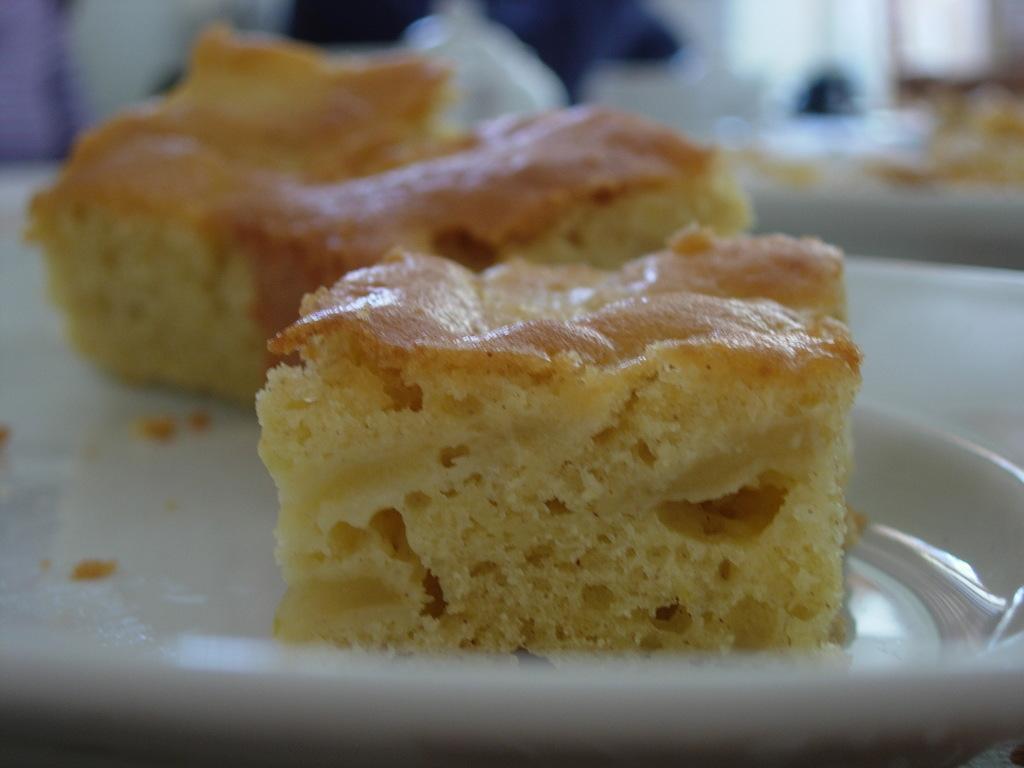How would you summarize this image in a sentence or two? In this image, there is a white color plate, in that place there are some cake pieces kept. 